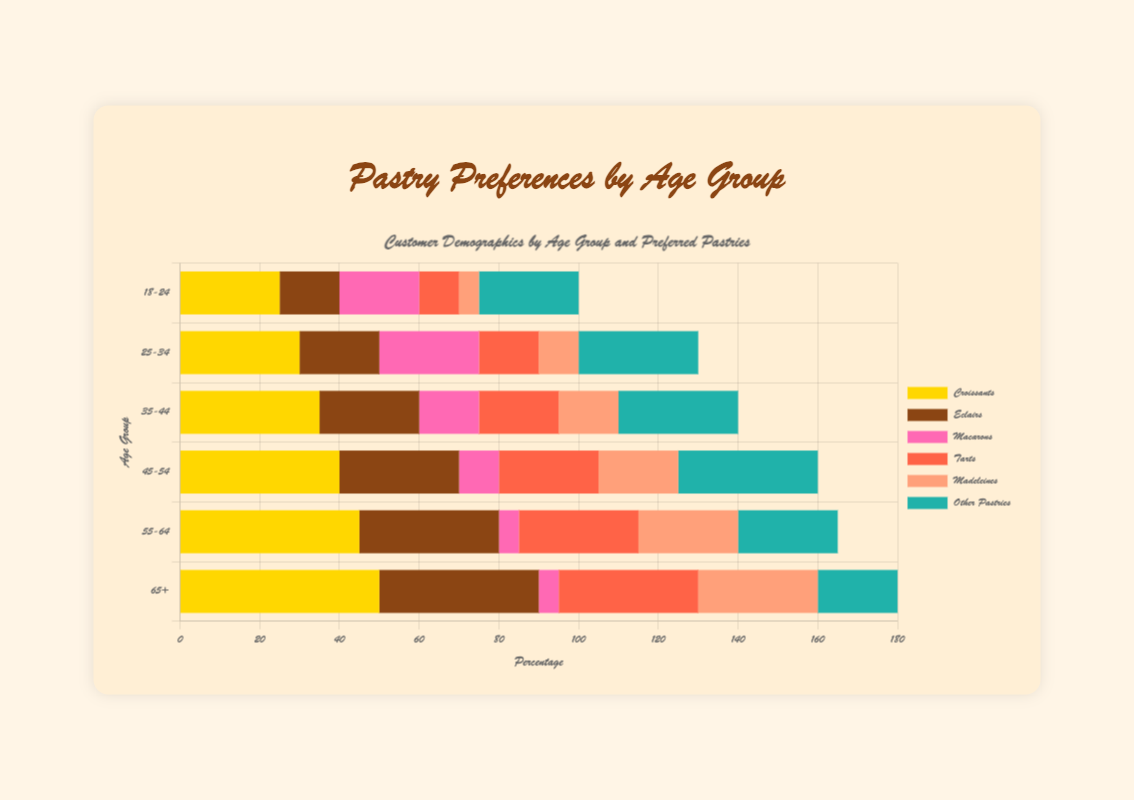Which age group has the highest preference for madeleines? To find which age group has the highest preference for madeleines, look at the bar segment labeled "Madeleines" in each age group row. The "65+" group has the largest visual segment.
Answer: 65+ Which age group shows the lowest preference for macarons? To find the lowest preference for macarons, observe the smallest "Macarons" segment, which is found in the "55-64" and "65+" groups, both with equal visual sizes.
Answer: 55-64 and 65+ Which pastry is the most popular among the 25-34 age group? Look at the segments for the 25-34 age group and identify the largest one. The largest bar segment is for "Other Pastries".
Answer: Other Pastries How does the preference for eclairs change from the 18-24 to 65+ age groups? To analyze the change, observe the "Eclairs" segments across age groups. The visual segments increase as age increases from 15 in 18-24 to 40 in 65+.
Answer: Increases What is the total percentage of customers aged 35-44 who prefer croissants and other pastries? Sum the segments for "Croissants" (35) and "Other Pastries" (30) in the 35-44 age group. 35 + 30 = 65.
Answer: 65 Which age group has equal preference for madeleines and other pastries? Visually inspect for equal segments for "Madeleines" and "Other Pastries". In the "55-64" group, both segments are indeed visually equal.
Answer: 55-64 What is the most popular pastry across all age groups? Observe the length of the segments for each pastry type across all age levels and find that "Croissants" generally have the longest segments.
Answer: Croissants Compare the preference for tarts between the 45-54 and 55-64 age groups. Examine the "Tarts" segments in both age groups. The "Tarts" segment in the 55-64 age group is slightly longer than in the 45-54 age group.
Answer: More preferred by 55-64 What is the difference in preference for macarons between the 18-24 and 25-34 age groups? Look at the "Macarons" segments in these age groups: 25-34 has 25 whereas 18-24 has 20. The difference is 25 - 20 = 5.
Answer: 5 Which age group has the smallest percentage preferencing tarts? Examine the "Tarts" segments in all groups and find the smallest visual segment in the "18-24" age group.
Answer: 18-24 